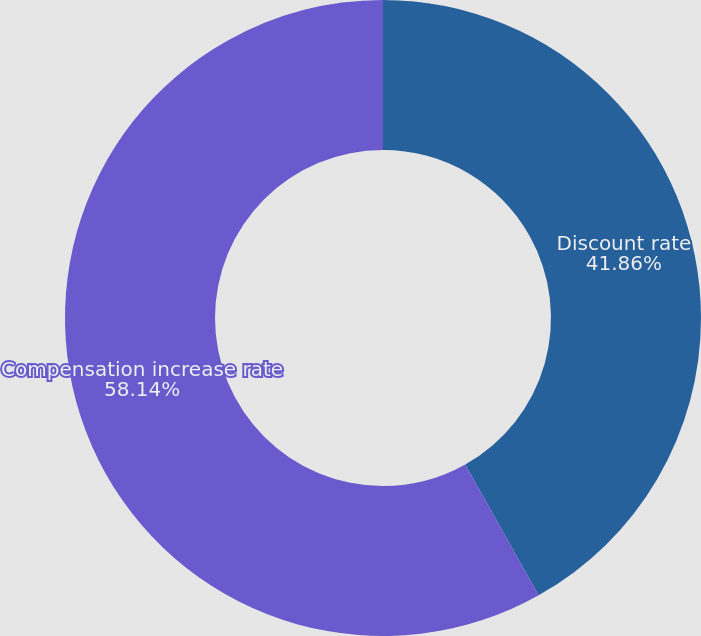Convert chart to OTSL. <chart><loc_0><loc_0><loc_500><loc_500><pie_chart><fcel>Discount rate<fcel>Compensation increase rate<nl><fcel>41.86%<fcel>58.14%<nl></chart> 